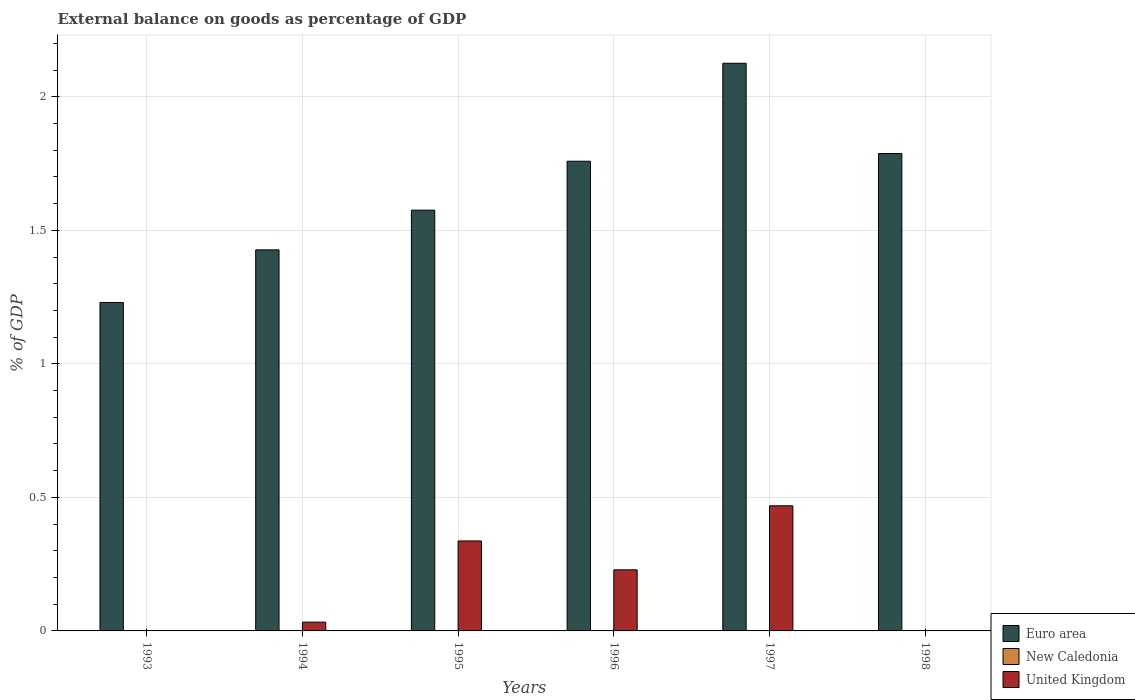How many different coloured bars are there?
Your answer should be compact. 2. Are the number of bars per tick equal to the number of legend labels?
Offer a terse response. No. How many bars are there on the 1st tick from the left?
Make the answer very short. 1. How many bars are there on the 2nd tick from the right?
Provide a short and direct response. 2. What is the external balance on goods as percentage of GDP in United Kingdom in 1996?
Your response must be concise. 0.23. Across all years, what is the maximum external balance on goods as percentage of GDP in Euro area?
Provide a short and direct response. 2.13. In which year was the external balance on goods as percentage of GDP in United Kingdom maximum?
Provide a short and direct response. 1997. What is the difference between the external balance on goods as percentage of GDP in Euro area in 1993 and that in 1995?
Keep it short and to the point. -0.35. What is the difference between the external balance on goods as percentage of GDP in Euro area in 1997 and the external balance on goods as percentage of GDP in New Caledonia in 1994?
Your response must be concise. 2.13. What is the average external balance on goods as percentage of GDP in United Kingdom per year?
Make the answer very short. 0.18. In the year 1996, what is the difference between the external balance on goods as percentage of GDP in United Kingdom and external balance on goods as percentage of GDP in Euro area?
Provide a succinct answer. -1.53. In how many years, is the external balance on goods as percentage of GDP in New Caledonia greater than 1.2 %?
Your answer should be very brief. 0. What is the ratio of the external balance on goods as percentage of GDP in Euro area in 1995 to that in 1997?
Offer a very short reply. 0.74. Is the difference between the external balance on goods as percentage of GDP in United Kingdom in 1995 and 1996 greater than the difference between the external balance on goods as percentage of GDP in Euro area in 1995 and 1996?
Provide a short and direct response. Yes. What is the difference between the highest and the second highest external balance on goods as percentage of GDP in United Kingdom?
Provide a succinct answer. 0.13. What is the difference between the highest and the lowest external balance on goods as percentage of GDP in United Kingdom?
Offer a very short reply. 0.47. Is the sum of the external balance on goods as percentage of GDP in United Kingdom in 1995 and 1997 greater than the maximum external balance on goods as percentage of GDP in Euro area across all years?
Offer a terse response. No. How many bars are there?
Your answer should be compact. 10. How many years are there in the graph?
Your answer should be compact. 6. How many legend labels are there?
Make the answer very short. 3. What is the title of the graph?
Provide a succinct answer. External balance on goods as percentage of GDP. What is the label or title of the X-axis?
Keep it short and to the point. Years. What is the label or title of the Y-axis?
Your response must be concise. % of GDP. What is the % of GDP in Euro area in 1993?
Provide a succinct answer. 1.23. What is the % of GDP in United Kingdom in 1993?
Offer a very short reply. 0. What is the % of GDP of Euro area in 1994?
Your response must be concise. 1.43. What is the % of GDP in New Caledonia in 1994?
Provide a succinct answer. 0. What is the % of GDP of United Kingdom in 1994?
Provide a short and direct response. 0.03. What is the % of GDP in Euro area in 1995?
Your response must be concise. 1.58. What is the % of GDP of New Caledonia in 1995?
Your answer should be compact. 0. What is the % of GDP of United Kingdom in 1995?
Offer a terse response. 0.34. What is the % of GDP in Euro area in 1996?
Your response must be concise. 1.76. What is the % of GDP of New Caledonia in 1996?
Ensure brevity in your answer.  0. What is the % of GDP of United Kingdom in 1996?
Keep it short and to the point. 0.23. What is the % of GDP in Euro area in 1997?
Provide a short and direct response. 2.13. What is the % of GDP of United Kingdom in 1997?
Your answer should be very brief. 0.47. What is the % of GDP in Euro area in 1998?
Make the answer very short. 1.79. What is the % of GDP of United Kingdom in 1998?
Offer a terse response. 0. Across all years, what is the maximum % of GDP of Euro area?
Your response must be concise. 2.13. Across all years, what is the maximum % of GDP of United Kingdom?
Keep it short and to the point. 0.47. Across all years, what is the minimum % of GDP in Euro area?
Give a very brief answer. 1.23. What is the total % of GDP of Euro area in the graph?
Offer a terse response. 9.91. What is the total % of GDP of United Kingdom in the graph?
Offer a terse response. 1.07. What is the difference between the % of GDP of Euro area in 1993 and that in 1994?
Provide a short and direct response. -0.2. What is the difference between the % of GDP of Euro area in 1993 and that in 1995?
Ensure brevity in your answer.  -0.35. What is the difference between the % of GDP of Euro area in 1993 and that in 1996?
Keep it short and to the point. -0.53. What is the difference between the % of GDP of Euro area in 1993 and that in 1997?
Your response must be concise. -0.9. What is the difference between the % of GDP in Euro area in 1993 and that in 1998?
Your answer should be compact. -0.56. What is the difference between the % of GDP in Euro area in 1994 and that in 1995?
Offer a terse response. -0.15. What is the difference between the % of GDP in United Kingdom in 1994 and that in 1995?
Your answer should be very brief. -0.3. What is the difference between the % of GDP of Euro area in 1994 and that in 1996?
Give a very brief answer. -0.33. What is the difference between the % of GDP of United Kingdom in 1994 and that in 1996?
Provide a short and direct response. -0.2. What is the difference between the % of GDP in Euro area in 1994 and that in 1997?
Offer a terse response. -0.7. What is the difference between the % of GDP in United Kingdom in 1994 and that in 1997?
Your answer should be very brief. -0.44. What is the difference between the % of GDP in Euro area in 1994 and that in 1998?
Ensure brevity in your answer.  -0.36. What is the difference between the % of GDP in Euro area in 1995 and that in 1996?
Your answer should be compact. -0.18. What is the difference between the % of GDP of United Kingdom in 1995 and that in 1996?
Ensure brevity in your answer.  0.11. What is the difference between the % of GDP in Euro area in 1995 and that in 1997?
Provide a succinct answer. -0.55. What is the difference between the % of GDP in United Kingdom in 1995 and that in 1997?
Make the answer very short. -0.13. What is the difference between the % of GDP in Euro area in 1995 and that in 1998?
Ensure brevity in your answer.  -0.21. What is the difference between the % of GDP in Euro area in 1996 and that in 1997?
Ensure brevity in your answer.  -0.37. What is the difference between the % of GDP in United Kingdom in 1996 and that in 1997?
Your response must be concise. -0.24. What is the difference between the % of GDP of Euro area in 1996 and that in 1998?
Offer a terse response. -0.03. What is the difference between the % of GDP in Euro area in 1997 and that in 1998?
Provide a short and direct response. 0.34. What is the difference between the % of GDP of Euro area in 1993 and the % of GDP of United Kingdom in 1994?
Your response must be concise. 1.2. What is the difference between the % of GDP in Euro area in 1993 and the % of GDP in United Kingdom in 1995?
Your answer should be compact. 0.89. What is the difference between the % of GDP of Euro area in 1993 and the % of GDP of United Kingdom in 1997?
Provide a short and direct response. 0.76. What is the difference between the % of GDP in Euro area in 1994 and the % of GDP in United Kingdom in 1995?
Keep it short and to the point. 1.09. What is the difference between the % of GDP in Euro area in 1994 and the % of GDP in United Kingdom in 1996?
Provide a succinct answer. 1.2. What is the difference between the % of GDP of Euro area in 1994 and the % of GDP of United Kingdom in 1997?
Make the answer very short. 0.96. What is the difference between the % of GDP in Euro area in 1995 and the % of GDP in United Kingdom in 1996?
Your response must be concise. 1.35. What is the difference between the % of GDP of Euro area in 1995 and the % of GDP of United Kingdom in 1997?
Your answer should be compact. 1.11. What is the difference between the % of GDP of Euro area in 1996 and the % of GDP of United Kingdom in 1997?
Keep it short and to the point. 1.29. What is the average % of GDP of Euro area per year?
Offer a terse response. 1.65. What is the average % of GDP in New Caledonia per year?
Make the answer very short. 0. What is the average % of GDP of United Kingdom per year?
Your answer should be compact. 0.18. In the year 1994, what is the difference between the % of GDP in Euro area and % of GDP in United Kingdom?
Keep it short and to the point. 1.39. In the year 1995, what is the difference between the % of GDP in Euro area and % of GDP in United Kingdom?
Give a very brief answer. 1.24. In the year 1996, what is the difference between the % of GDP in Euro area and % of GDP in United Kingdom?
Ensure brevity in your answer.  1.53. In the year 1997, what is the difference between the % of GDP of Euro area and % of GDP of United Kingdom?
Provide a succinct answer. 1.66. What is the ratio of the % of GDP of Euro area in 1993 to that in 1994?
Your answer should be very brief. 0.86. What is the ratio of the % of GDP of Euro area in 1993 to that in 1995?
Your answer should be very brief. 0.78. What is the ratio of the % of GDP in Euro area in 1993 to that in 1996?
Offer a very short reply. 0.7. What is the ratio of the % of GDP in Euro area in 1993 to that in 1997?
Provide a succinct answer. 0.58. What is the ratio of the % of GDP of Euro area in 1993 to that in 1998?
Provide a succinct answer. 0.69. What is the ratio of the % of GDP in Euro area in 1994 to that in 1995?
Make the answer very short. 0.91. What is the ratio of the % of GDP in United Kingdom in 1994 to that in 1995?
Offer a very short reply. 0.1. What is the ratio of the % of GDP of Euro area in 1994 to that in 1996?
Your answer should be very brief. 0.81. What is the ratio of the % of GDP in United Kingdom in 1994 to that in 1996?
Provide a short and direct response. 0.14. What is the ratio of the % of GDP of Euro area in 1994 to that in 1997?
Your answer should be very brief. 0.67. What is the ratio of the % of GDP in United Kingdom in 1994 to that in 1997?
Your answer should be very brief. 0.07. What is the ratio of the % of GDP of Euro area in 1994 to that in 1998?
Your answer should be very brief. 0.8. What is the ratio of the % of GDP of Euro area in 1995 to that in 1996?
Your answer should be compact. 0.9. What is the ratio of the % of GDP of United Kingdom in 1995 to that in 1996?
Your answer should be compact. 1.47. What is the ratio of the % of GDP in Euro area in 1995 to that in 1997?
Your response must be concise. 0.74. What is the ratio of the % of GDP of United Kingdom in 1995 to that in 1997?
Provide a succinct answer. 0.72. What is the ratio of the % of GDP of Euro area in 1995 to that in 1998?
Make the answer very short. 0.88. What is the ratio of the % of GDP of Euro area in 1996 to that in 1997?
Provide a succinct answer. 0.83. What is the ratio of the % of GDP of United Kingdom in 1996 to that in 1997?
Make the answer very short. 0.49. What is the ratio of the % of GDP in Euro area in 1996 to that in 1998?
Offer a very short reply. 0.98. What is the ratio of the % of GDP in Euro area in 1997 to that in 1998?
Your answer should be very brief. 1.19. What is the difference between the highest and the second highest % of GDP of Euro area?
Provide a short and direct response. 0.34. What is the difference between the highest and the second highest % of GDP in United Kingdom?
Ensure brevity in your answer.  0.13. What is the difference between the highest and the lowest % of GDP in Euro area?
Give a very brief answer. 0.9. What is the difference between the highest and the lowest % of GDP of United Kingdom?
Give a very brief answer. 0.47. 